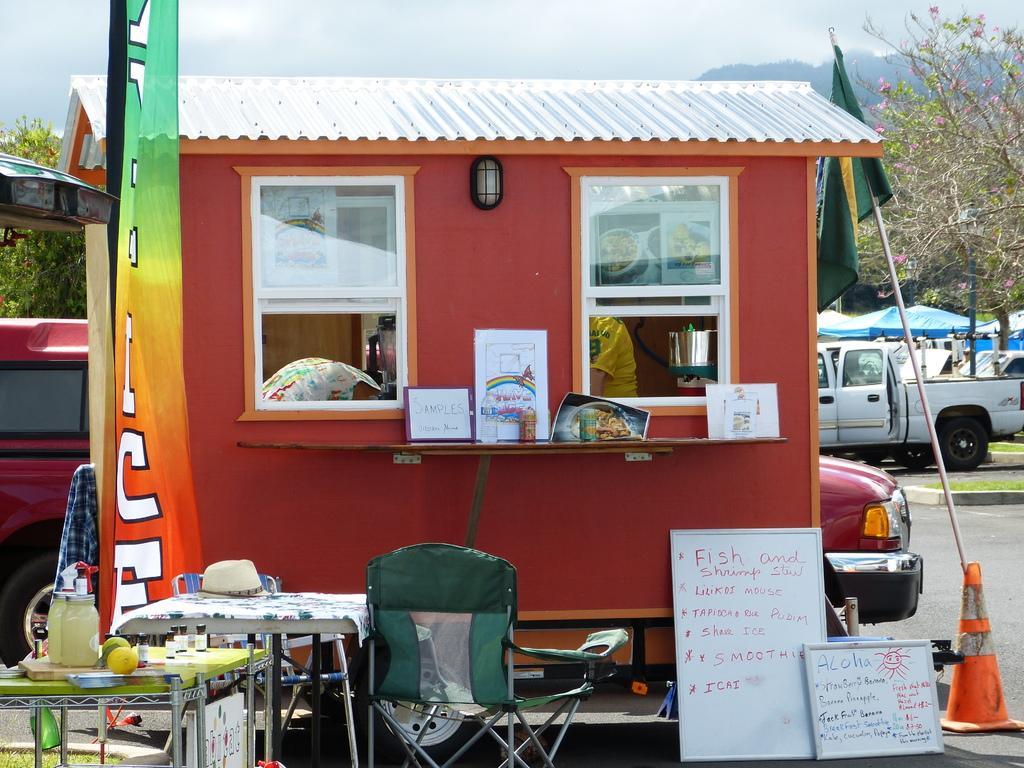Please provide a concise description of this image. This is a small room with two windows and a light on it. There are two persons in the room. In the front there are tables,chairs and boards. On the table there are fruits,hat and jars. In the background there are vehicles,trees,sky,hoarding and a flag. 